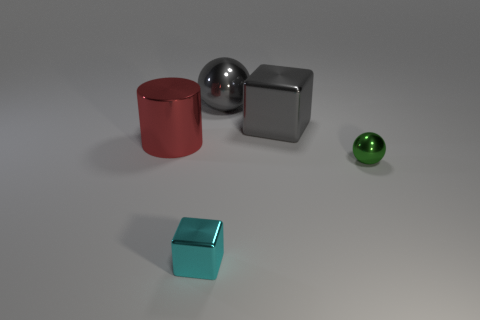Subtract all blocks. How many objects are left? 3 Subtract 1 cylinders. How many cylinders are left? 0 Add 4 large cyan matte balls. How many large cyan matte balls exist? 4 Add 1 large gray metallic cubes. How many objects exist? 6 Subtract 0 red spheres. How many objects are left? 5 Subtract all gray cubes. Subtract all red cylinders. How many cubes are left? 1 Subtract all purple cubes. How many brown cylinders are left? 0 Subtract all big gray rubber objects. Subtract all small blocks. How many objects are left? 4 Add 5 spheres. How many spheres are left? 7 